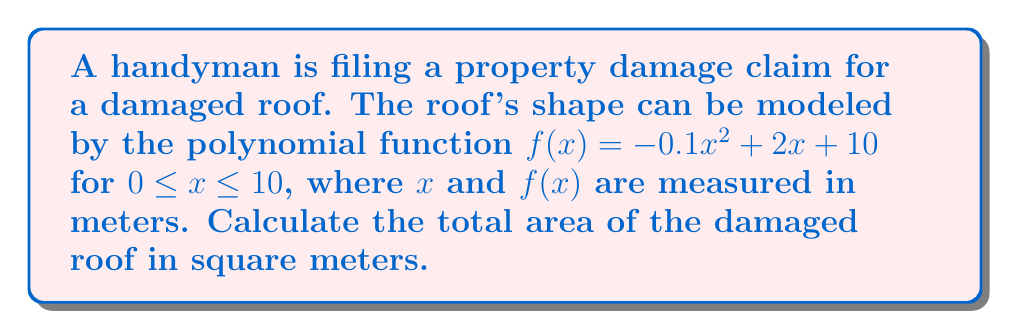Solve this math problem. To calculate the area under a polynomial function, we need to use definite integration. The steps are as follows:

1) The area under the curve is given by the definite integral:

   $$A = \int_0^{10} f(x) dx = \int_0^{10} (-0.1x^2 + 2x + 10) dx$$

2) Integrate the function:
   
   $$\int (-0.1x^2 + 2x + 10) dx = -\frac{1}{30}x^3 + x^2 + 10x + C$$

3) Apply the limits of integration:

   $$A = [-\frac{1}{30}x^3 + x^2 + 10x]_0^{10}$$

4) Evaluate at the upper limit:

   $$-\frac{1}{30}(10^3) + (10^2) + 10(10) = -\frac{1000}{30} + 100 + 100 = -33.33 + 200 = 166.67$$

5) Evaluate at the lower limit:

   $$-\frac{1}{30}(0^3) + (0^2) + 10(0) = 0$$

6) Subtract the lower limit from the upper limit:

   $$A = 166.67 - 0 = 166.67$$

Therefore, the total area of the damaged roof is approximately 166.67 square meters.
Answer: 166.67 square meters 